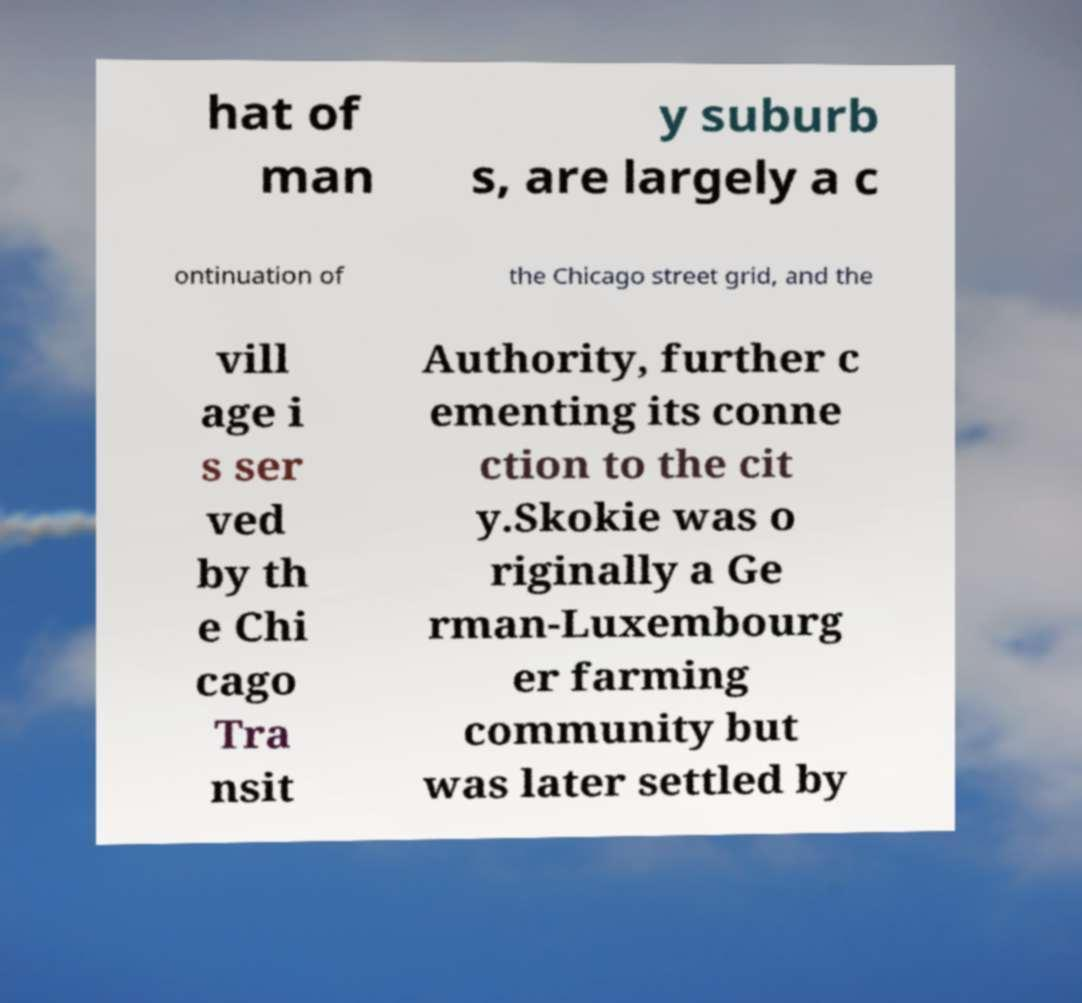I need the written content from this picture converted into text. Can you do that? hat of man y suburb s, are largely a c ontinuation of the Chicago street grid, and the vill age i s ser ved by th e Chi cago Tra nsit Authority, further c ementing its conne ction to the cit y.Skokie was o riginally a Ge rman-Luxembourg er farming community but was later settled by 